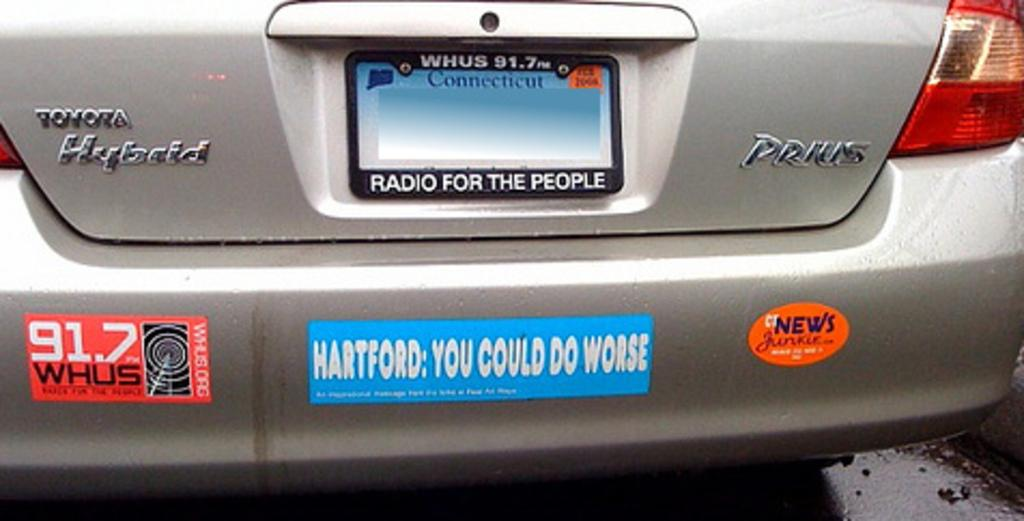Provide a one-sentence caption for the provided image. a sign on the back of a car that says Hartford on it. 